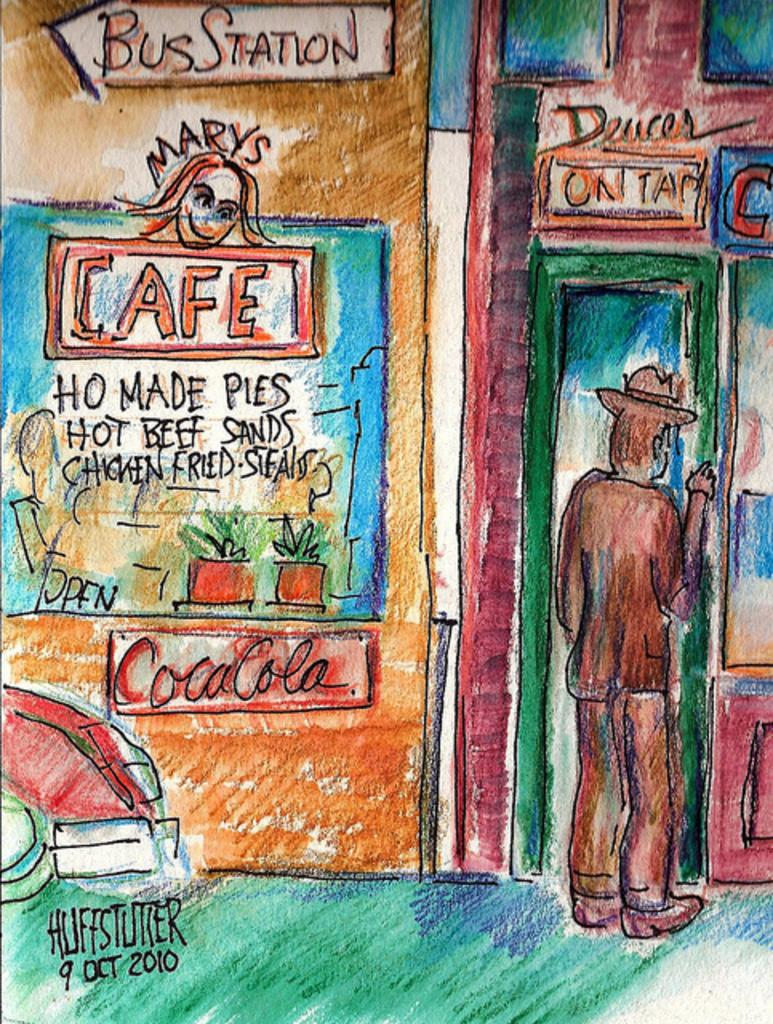What is the main subject of the image? There is a painting in the image. What type of popcorn is being served by the crow in the image? There is no popcorn or crow present in the image; it only features a painting. 